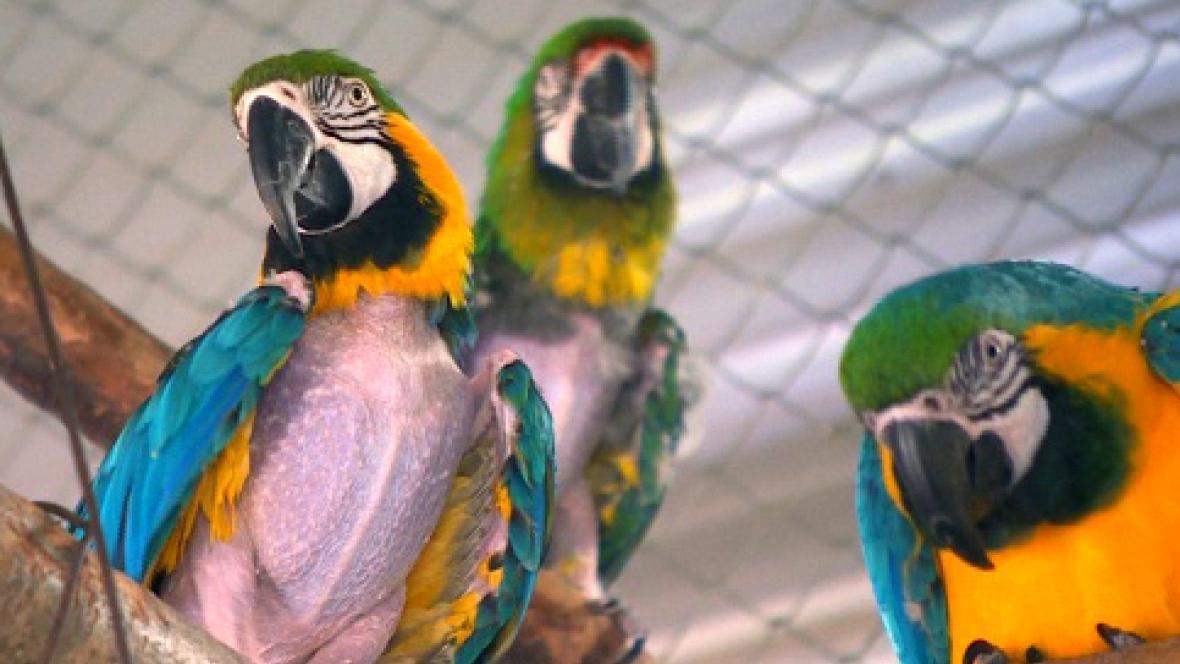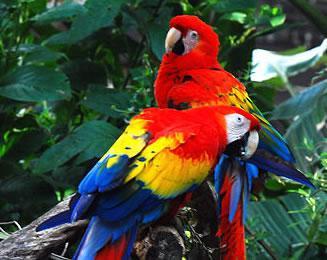The first image is the image on the left, the second image is the image on the right. Assess this claim about the two images: "Each image shows a row of three birds perched on a branch, and no row of birds all share the same coloring.". Correct or not? Answer yes or no. No. 